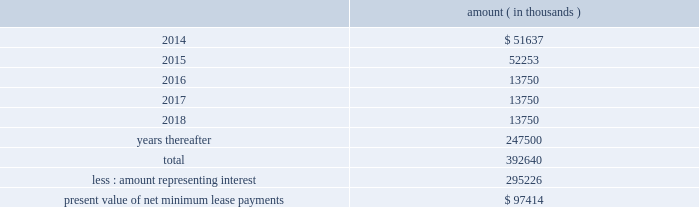Entergy corporation and subsidiaries notes to financial statements this difference as a regulatory asset or liability on an ongoing basis , resulting in a zero net balance for the regulatory asset at the end of the lease term .
The amount was a net regulatory liability of $ 61.6 million and $ 27.8 million as of december 31 , 2013 and 2012 , respectively .
As of december 31 , 2013 , system energy had future minimum lease payments ( reflecting an implicit rate of 5.13% ( 5.13 % ) ) , which are recorded as long-term debt , as follows : amount ( in thousands ) .

What portion of the total future minimum lease payments for system energy is due in the next 12 months? 
Computations: (51637 / 392640)
Answer: 0.13151. 